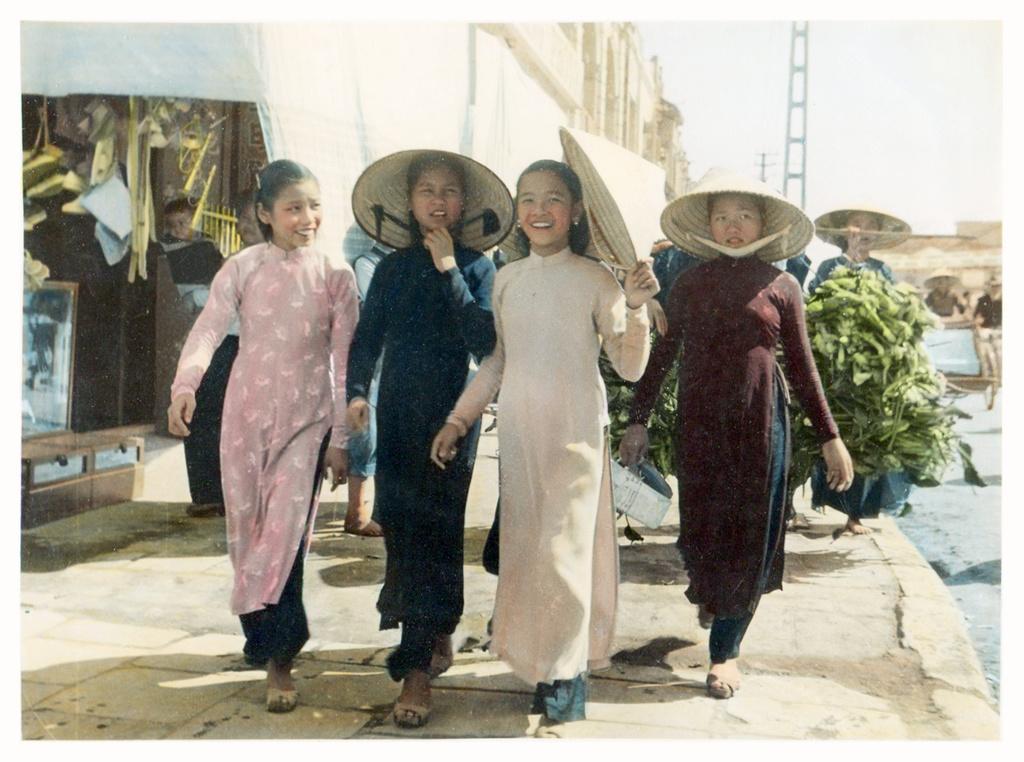In one or two sentences, can you explain what this image depicts? In this image I can see group of people standing. In front the person is wearing cream and green color dress. In the background I can see few buildings and I can also see the stall and the sky is in white color. 